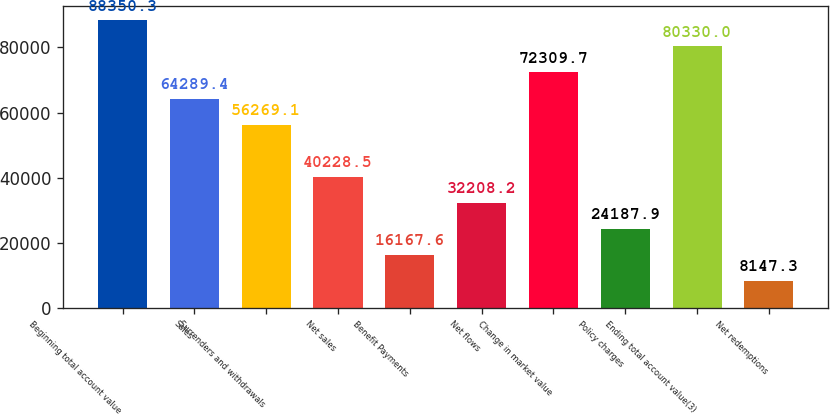Convert chart. <chart><loc_0><loc_0><loc_500><loc_500><bar_chart><fcel>Beginning total account value<fcel>Sales<fcel>Surrenders and withdrawals<fcel>Net sales<fcel>Benefit Payments<fcel>Net flows<fcel>Change in market value<fcel>Policy charges<fcel>Ending total account value(3)<fcel>Net redemptions<nl><fcel>88350.3<fcel>64289.4<fcel>56269.1<fcel>40228.5<fcel>16167.6<fcel>32208.2<fcel>72309.7<fcel>24187.9<fcel>80330<fcel>8147.3<nl></chart> 